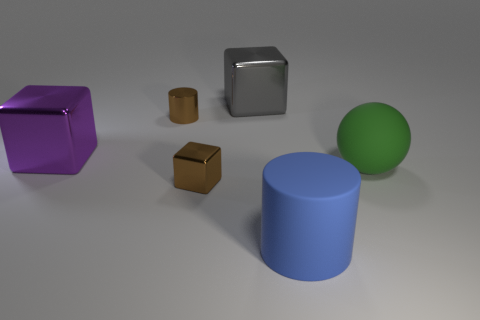Add 1 large gray cubes. How many objects exist? 7 Subtract all cylinders. How many objects are left? 4 Subtract all rubber spheres. Subtract all brown cylinders. How many objects are left? 4 Add 5 large blue matte cylinders. How many large blue matte cylinders are left? 6 Add 1 tiny brown cylinders. How many tiny brown cylinders exist? 2 Subtract 0 gray balls. How many objects are left? 6 